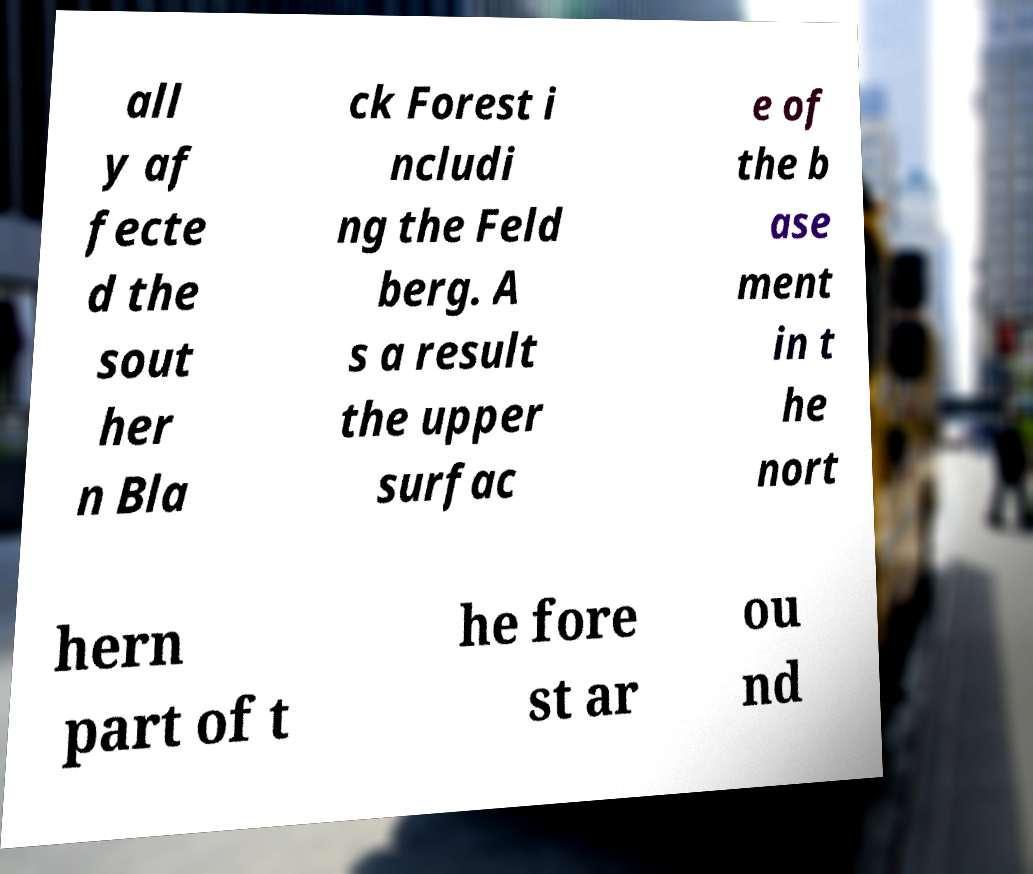Please identify and transcribe the text found in this image. all y af fecte d the sout her n Bla ck Forest i ncludi ng the Feld berg. A s a result the upper surfac e of the b ase ment in t he nort hern part of t he fore st ar ou nd 